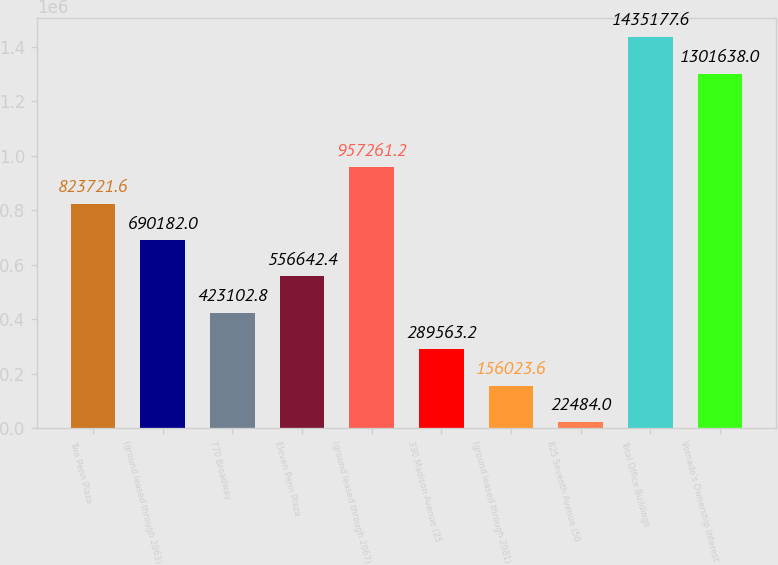<chart> <loc_0><loc_0><loc_500><loc_500><bar_chart><fcel>Two Penn Plaza<fcel>(ground leased through 2063)<fcel>770 Broadway<fcel>Eleven Penn Plaza<fcel>(ground leased through 2067)<fcel>330 Madison Avenue (25<fcel>(ground leased through 2081)<fcel>825 Seventh Avenue (50<fcel>Total Office Buildings<fcel>Vornado's Ownership Interest<nl><fcel>823722<fcel>690182<fcel>423103<fcel>556642<fcel>957261<fcel>289563<fcel>156024<fcel>22484<fcel>1.43518e+06<fcel>1.30164e+06<nl></chart> 